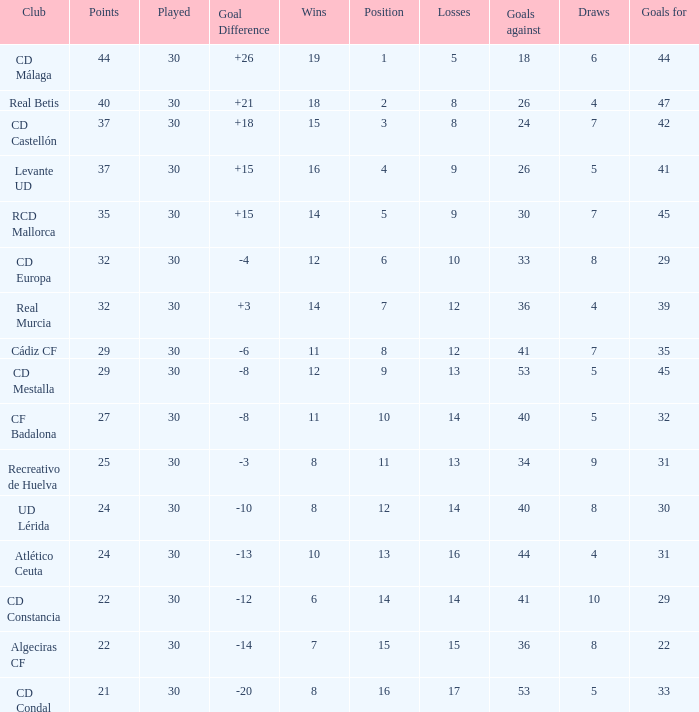What losses occur when the goal difference surpasses 26? None. 